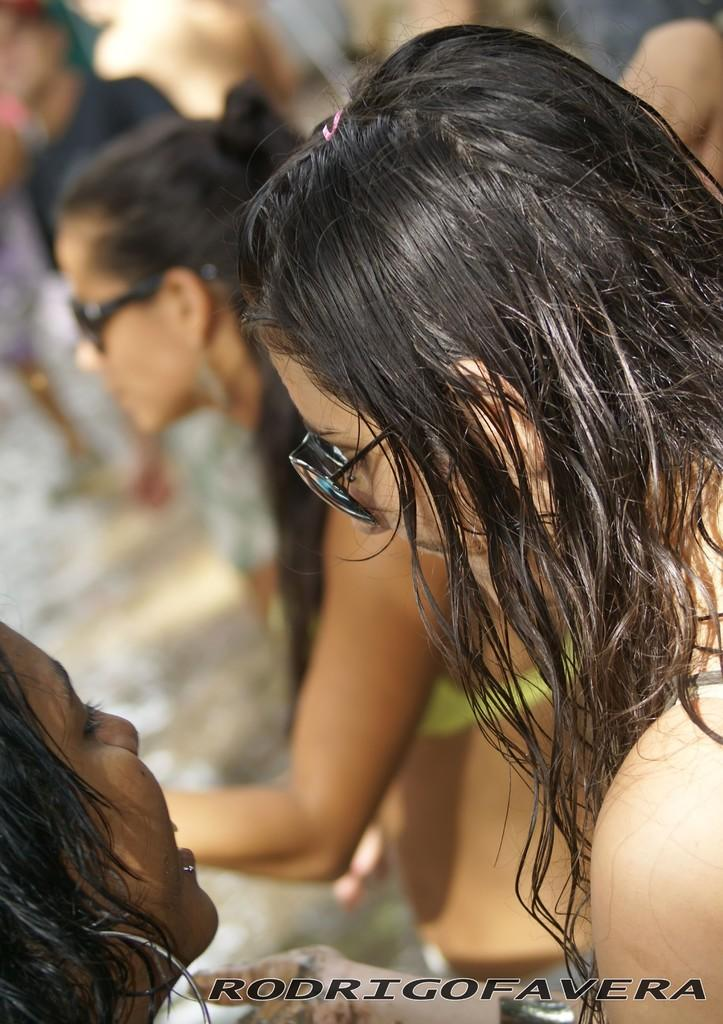Who or what is present in the image? There are people in the image. What are the people wearing? The people are wearing sunglasses. Is there any text visible in the image? Yes, there is text at the bottom right corner of the image. How many pigs can be seen in the image? There are no pigs present in the image. What is the value of the quarter shown in the image? There is no quarter present in the image. 